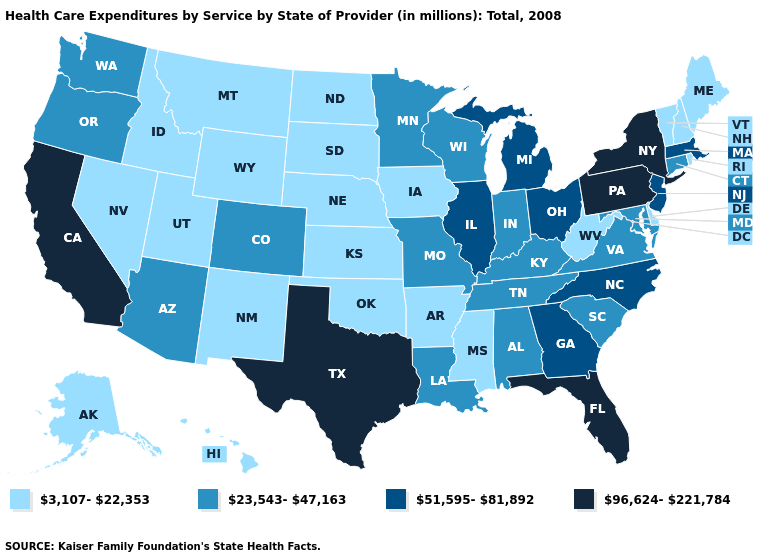Name the states that have a value in the range 3,107-22,353?
Give a very brief answer. Alaska, Arkansas, Delaware, Hawaii, Idaho, Iowa, Kansas, Maine, Mississippi, Montana, Nebraska, Nevada, New Hampshire, New Mexico, North Dakota, Oklahoma, Rhode Island, South Dakota, Utah, Vermont, West Virginia, Wyoming. What is the lowest value in the USA?
Short answer required. 3,107-22,353. What is the lowest value in states that border Georgia?
Quick response, please. 23,543-47,163. What is the lowest value in states that border North Carolina?
Answer briefly. 23,543-47,163. Does the first symbol in the legend represent the smallest category?
Keep it brief. Yes. What is the highest value in the West ?
Concise answer only. 96,624-221,784. Name the states that have a value in the range 96,624-221,784?
Concise answer only. California, Florida, New York, Pennsylvania, Texas. What is the lowest value in states that border Montana?
Concise answer only. 3,107-22,353. Does the first symbol in the legend represent the smallest category?
Be succinct. Yes. Name the states that have a value in the range 51,595-81,892?
Be succinct. Georgia, Illinois, Massachusetts, Michigan, New Jersey, North Carolina, Ohio. What is the highest value in the USA?
Be succinct. 96,624-221,784. What is the value of North Dakota?
Give a very brief answer. 3,107-22,353. What is the value of New Mexico?
Short answer required. 3,107-22,353. What is the value of Nebraska?
Answer briefly. 3,107-22,353. What is the highest value in states that border South Dakota?
Quick response, please. 23,543-47,163. 